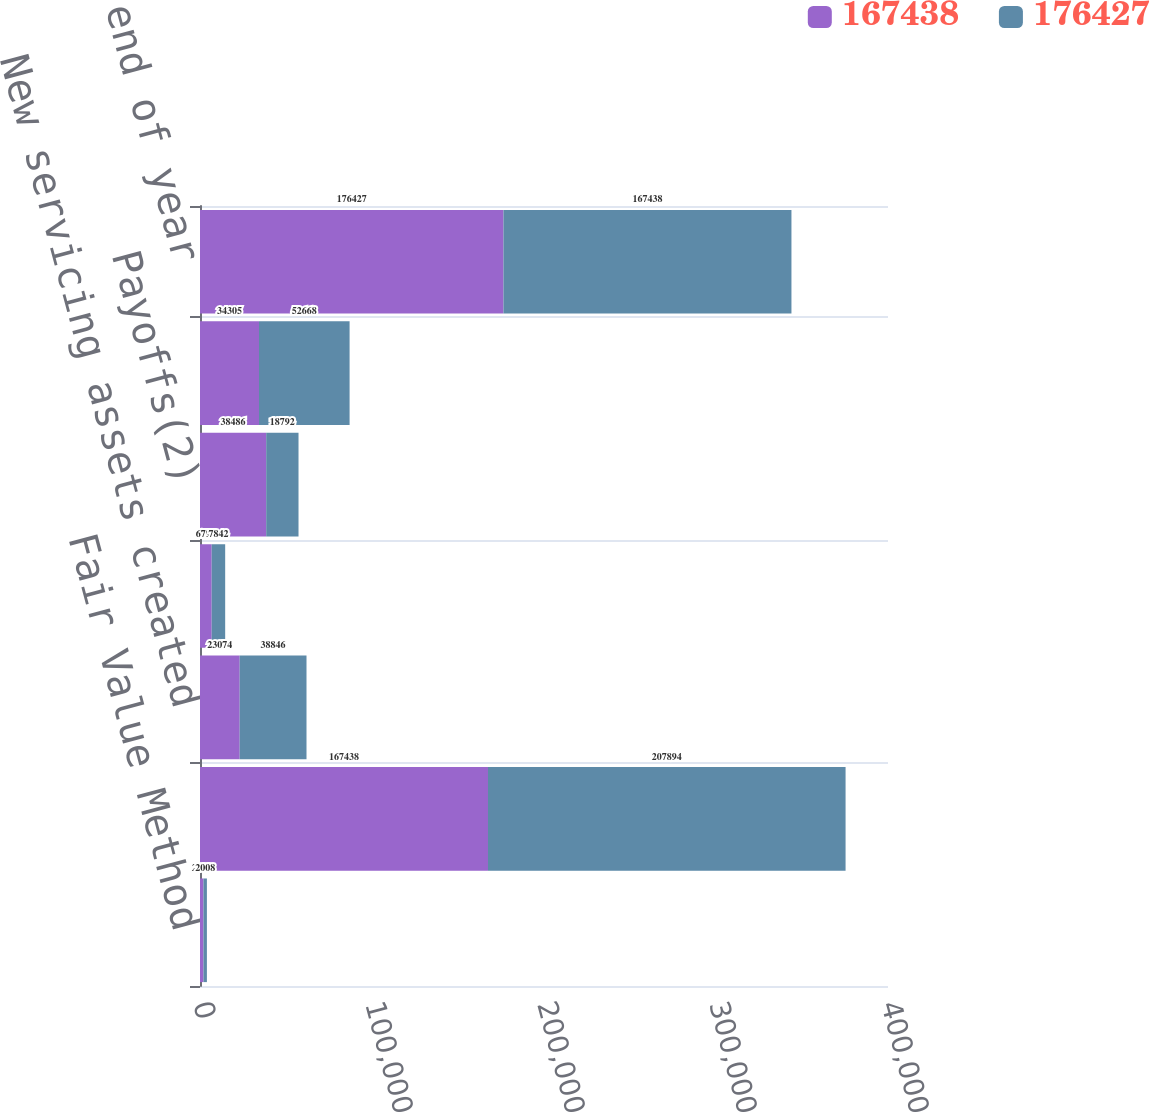Convert chart to OTSL. <chart><loc_0><loc_0><loc_500><loc_500><stacked_bar_chart><ecel><fcel>Fair Value Method<fcel>Fairvalue beginning ofyear<fcel>New servicing assets created<fcel>Time decay(1)<fcel>Payoffs(2)<fcel>Changes in valuation inputs or<fcel>Fair value end of year<nl><fcel>167438<fcel>2009<fcel>167438<fcel>23074<fcel>6798<fcel>38486<fcel>34305<fcel>176427<nl><fcel>176427<fcel>2008<fcel>207894<fcel>38846<fcel>7842<fcel>18792<fcel>52668<fcel>167438<nl></chart> 